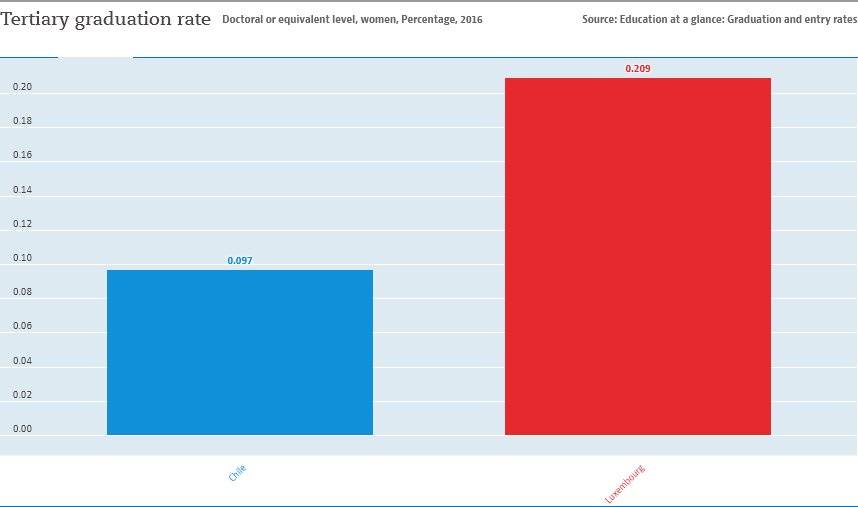Indicate a few pertinent items in this graphic. The smallest bar has a value of approximately 0.097... The value of the smallest bar is not half the value of the largest bar. 